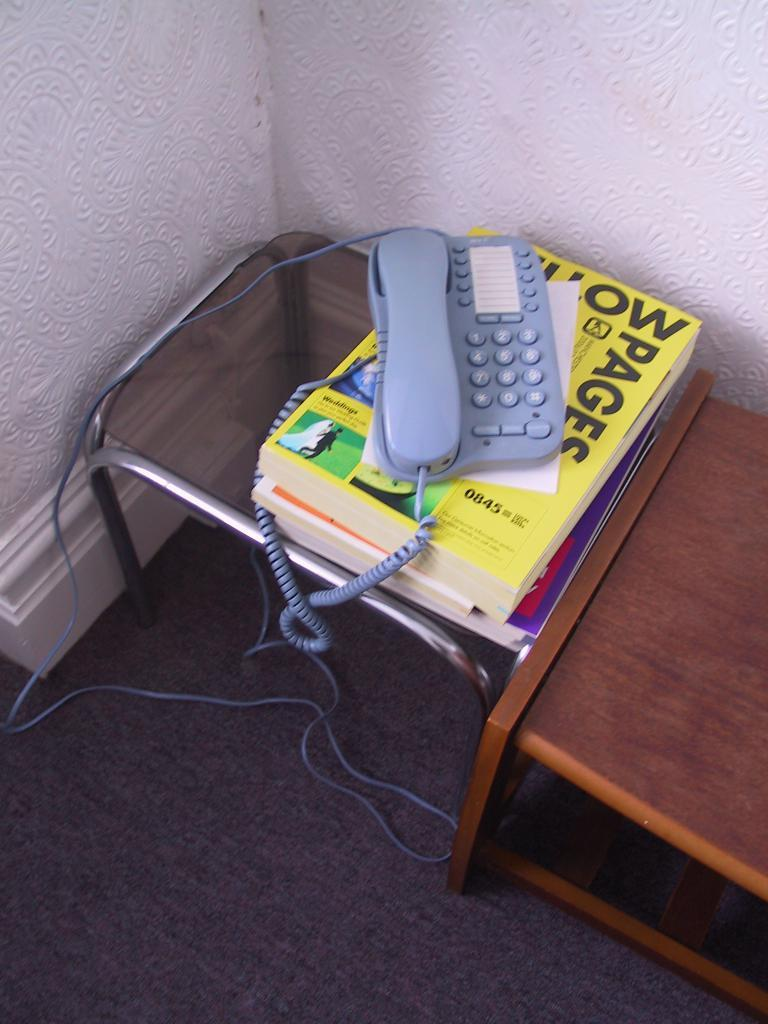What type of phone is visible in the image? There is a landline phone in the image. What is the landline phone resting on? The landline phone is on books. Where are the books and phone located? They are on a table. What can be seen in the background of the image? There is another table, a wall, and a carpet in the background of the image. How does the dust affect the phone and books in the image? There is no dust visible in the image, so it cannot affect the phone and books. 